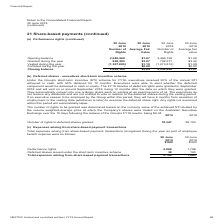According to Nextdc's financial document, How was the fair value of the rights at the date of valuation determined? using the Black-Scholes Option Pricing Model to be equal to the volume weighted-average price (VWAP) ending on the day before the grant date, less the dividends expected over the period from the expected grant date to the completion of the measurement period, adjusted for the expected probability of achieving the vesting conditions.. The document states: "the rights at the date of valuation was determined using the Black-Scholes Option Pricing Model to be equal to the volume weighted-average price (VWAP..." Also, When will the vesting of the rights be tested on? on or around the day following the release of each of the annual results for the years ended 30 June 2019, 2020 and 2021 respectively.. The document states: "ement period. Vesting of the rights will be tested on or around the day following the release of each of the annual results for the years ended 30 Jun..." Also, How much performance rights was granted in FY18? According to the financial document, 762,577. The relevant text states: "0,195 $1.26 Granted during the year 828,285 $3.07 762,577 $3.32 Vested during the year (1,307,885) $1.19 (1,273,812) $1.09 Forfeited during the year - $0.00..." Also, can you calculate: What was the average difference between number of rights in opening and closing balance for both years? To answer this question, I need to perform calculations using the financial data. The calculation is: ((2,948,960 - 2,469,360) + (3,460,195 - 2,948,960)) / 2 , which equals 495417.5. This is based on the information: "Opening balance 2,948,960 $1.87 3,460,195 $1.26 Granted during the year 828,285 $3.07 762,577 $3.32 Vested during the year (1 Opening balance 2,948,960 $1.87 3,460,195 $1.26 Granted during the year 82..." The key data points involved are: 2, 2,469,360, 2,948,960. Additionally, Which year had more rights vested? According to the financial document, 2019. The relevant text states: "otes to the Consolidated Financial Report 30 June 2019 (continued)..." Also, can you calculate: What was the percentage change in average fair value at closing balance between 2018 and 2019? To answer this question, I need to perform calculations using the financial data. The calculation is: (2.64 - 1.87) / 1.87 , which equals 41.18 (percentage). This is based on the information: "Opening balance 2,948,960 $1.87 3,460,195 $1.26 Granted during the year 828,285 $3.07 762,577 $3.32 Vested during the year (1,307,8 e year - $0.00 - $0.00 Closing balance 2,469,360 $2.64 2,948,960 $1...." The key data points involved are: 1.87, 2.64. 